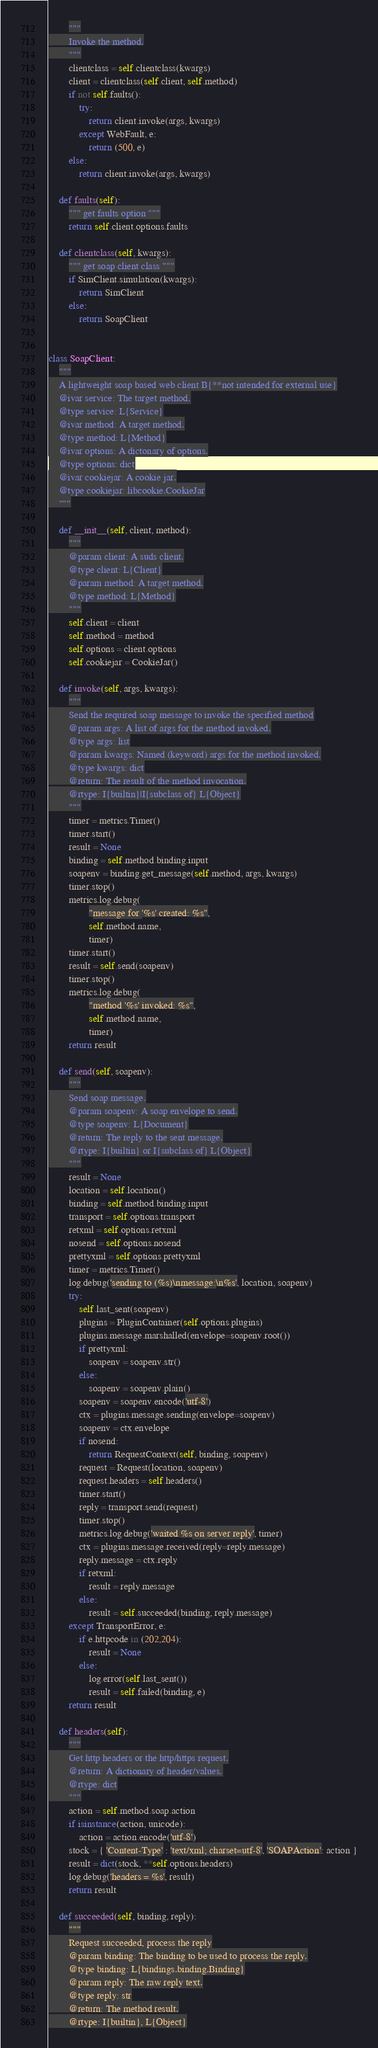Convert code to text. <code><loc_0><loc_0><loc_500><loc_500><_Python_>        """
        Invoke the method.
        """
        clientclass = self.clientclass(kwargs)
        client = clientclass(self.client, self.method)
        if not self.faults():
            try:
                return client.invoke(args, kwargs)
            except WebFault, e:
                return (500, e)
        else:
            return client.invoke(args, kwargs)
        
    def faults(self):
        """ get faults option """
        return self.client.options.faults
        
    def clientclass(self, kwargs):
        """ get soap client class """
        if SimClient.simulation(kwargs):
            return SimClient
        else:
            return SoapClient


class SoapClient:
    """
    A lightweight soap based web client B{**not intended for external use}
    @ivar service: The target method.
    @type service: L{Service}
    @ivar method: A target method.
    @type method: L{Method}
    @ivar options: A dictonary of options.
    @type options: dict
    @ivar cookiejar: A cookie jar.
    @type cookiejar: libcookie.CookieJar
    """

    def __init__(self, client, method):
        """
        @param client: A suds client.
        @type client: L{Client}
        @param method: A target method.
        @type method: L{Method}
        """
        self.client = client
        self.method = method
        self.options = client.options
        self.cookiejar = CookieJar()
        
    def invoke(self, args, kwargs):
        """
        Send the required soap message to invoke the specified method
        @param args: A list of args for the method invoked.
        @type args: list
        @param kwargs: Named (keyword) args for the method invoked.
        @type kwargs: dict
        @return: The result of the method invocation.
        @rtype: I{builtin}|I{subclass of} L{Object}
        """
        timer = metrics.Timer()
        timer.start()
        result = None
        binding = self.method.binding.input
        soapenv = binding.get_message(self.method, args, kwargs)
        timer.stop()
        metrics.log.debug(
                "message for '%s' created: %s",
                self.method.name,
                timer)
        timer.start()
        result = self.send(soapenv)
        timer.stop()
        metrics.log.debug(
                "method '%s' invoked: %s",
                self.method.name,
                timer)
        return result
    
    def send(self, soapenv):
        """
        Send soap message.
        @param soapenv: A soap envelope to send.
        @type soapenv: L{Document}
        @return: The reply to the sent message.
        @rtype: I{builtin} or I{subclass of} L{Object}
        """
        result = None
        location = self.location()
        binding = self.method.binding.input
        transport = self.options.transport
        retxml = self.options.retxml
        nosend = self.options.nosend
        prettyxml = self.options.prettyxml
        timer = metrics.Timer()
        log.debug('sending to (%s)\nmessage:\n%s', location, soapenv)
        try:
            self.last_sent(soapenv)
            plugins = PluginContainer(self.options.plugins)
            plugins.message.marshalled(envelope=soapenv.root())
            if prettyxml:
                soapenv = soapenv.str()
            else:
                soapenv = soapenv.plain()
            soapenv = soapenv.encode('utf-8')
            ctx = plugins.message.sending(envelope=soapenv)
            soapenv = ctx.envelope
            if nosend:
                return RequestContext(self, binding, soapenv)
            request = Request(location, soapenv)
            request.headers = self.headers()
            timer.start()
            reply = transport.send(request)
            timer.stop()
            metrics.log.debug('waited %s on server reply', timer)
            ctx = plugins.message.received(reply=reply.message)
            reply.message = ctx.reply
            if retxml:
                result = reply.message
            else:
                result = self.succeeded(binding, reply.message)
        except TransportError, e:
            if e.httpcode in (202,204):
                result = None
            else:
                log.error(self.last_sent())
                result = self.failed(binding, e)
        return result
    
    def headers(self):
        """
        Get http headers or the http/https request.
        @return: A dictionary of header/values.
        @rtype: dict
        """
        action = self.method.soap.action
        if isinstance(action, unicode):
            action = action.encode('utf-8')
        stock = { 'Content-Type' : 'text/xml; charset=utf-8', 'SOAPAction': action }
        result = dict(stock, **self.options.headers)
        log.debug('headers = %s', result)
        return result
    
    def succeeded(self, binding, reply):
        """
        Request succeeded, process the reply
        @param binding: The binding to be used to process the reply.
        @type binding: L{bindings.binding.Binding}
        @param reply: The raw reply text.
        @type reply: str
        @return: The method result.
        @rtype: I{builtin}, L{Object}</code> 